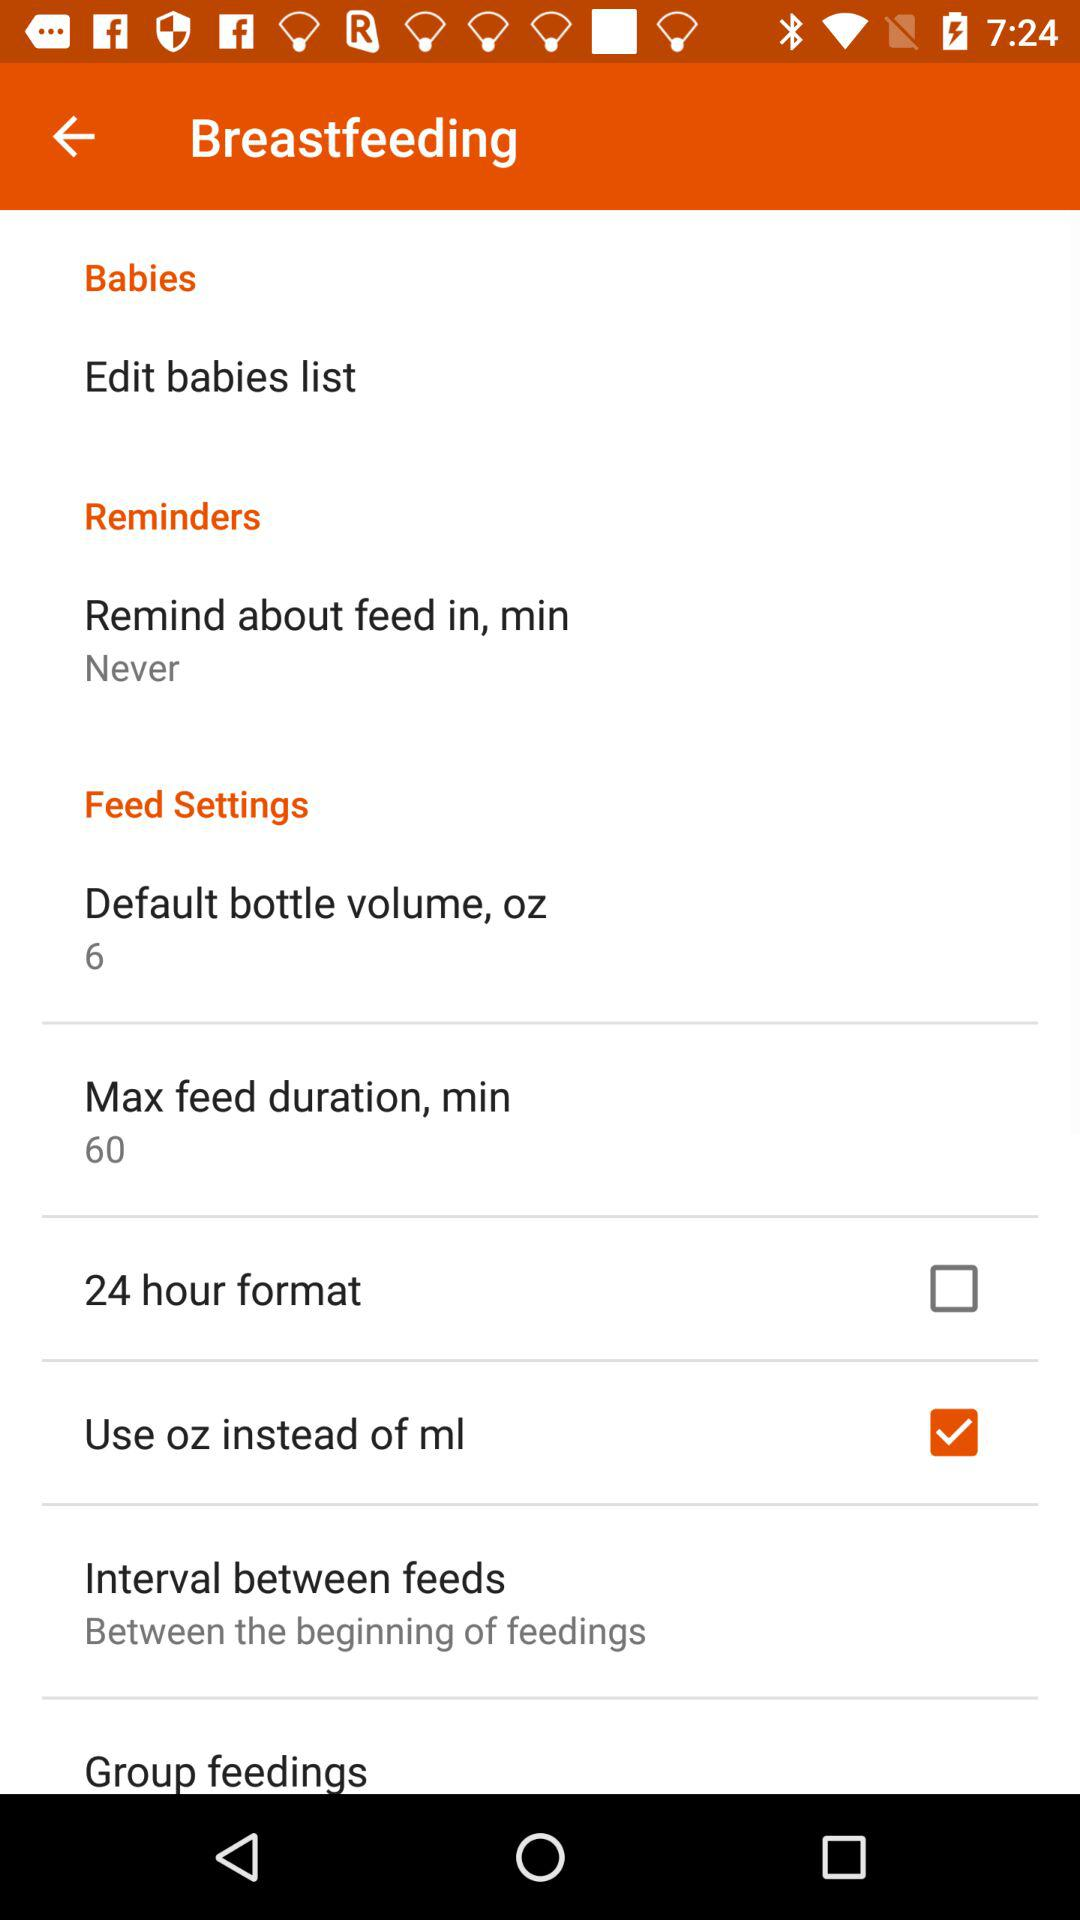What is the maximum feed duration in minutes? The maximum feed duration is 60 minutes. 